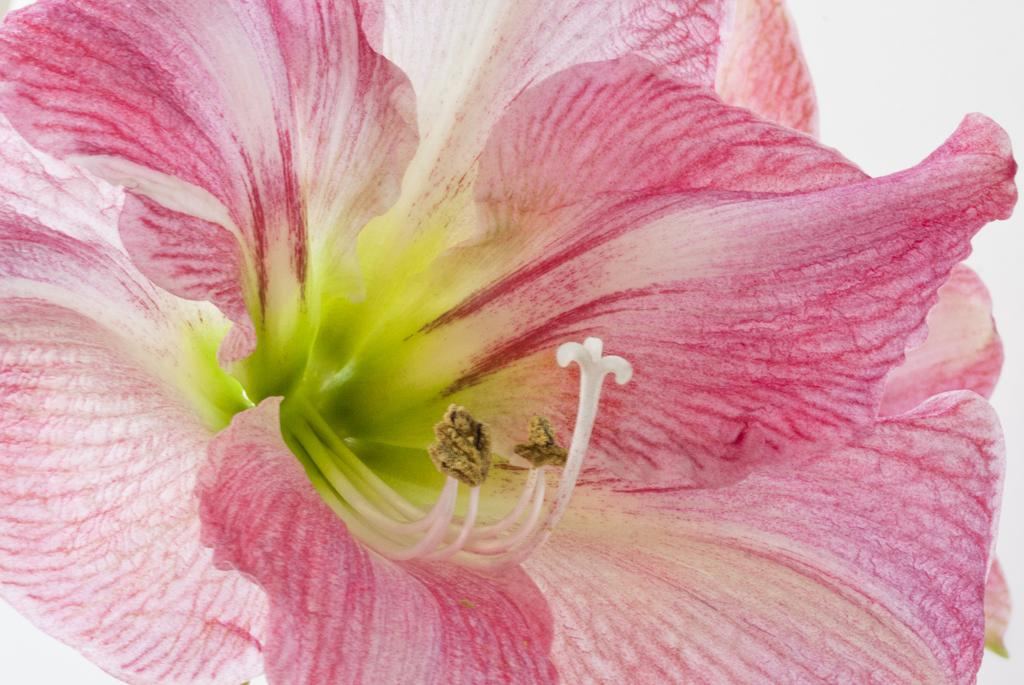What is the dominant color of the flower in the foreground of the image? The flower in the foreground of the image is pink. What is the color of the object in the background of the image? The object in the background of the image is white. What type of sink can be seen in the image? There is no sink present in the image. Is the church visible in the image? There is no church present in the image. 